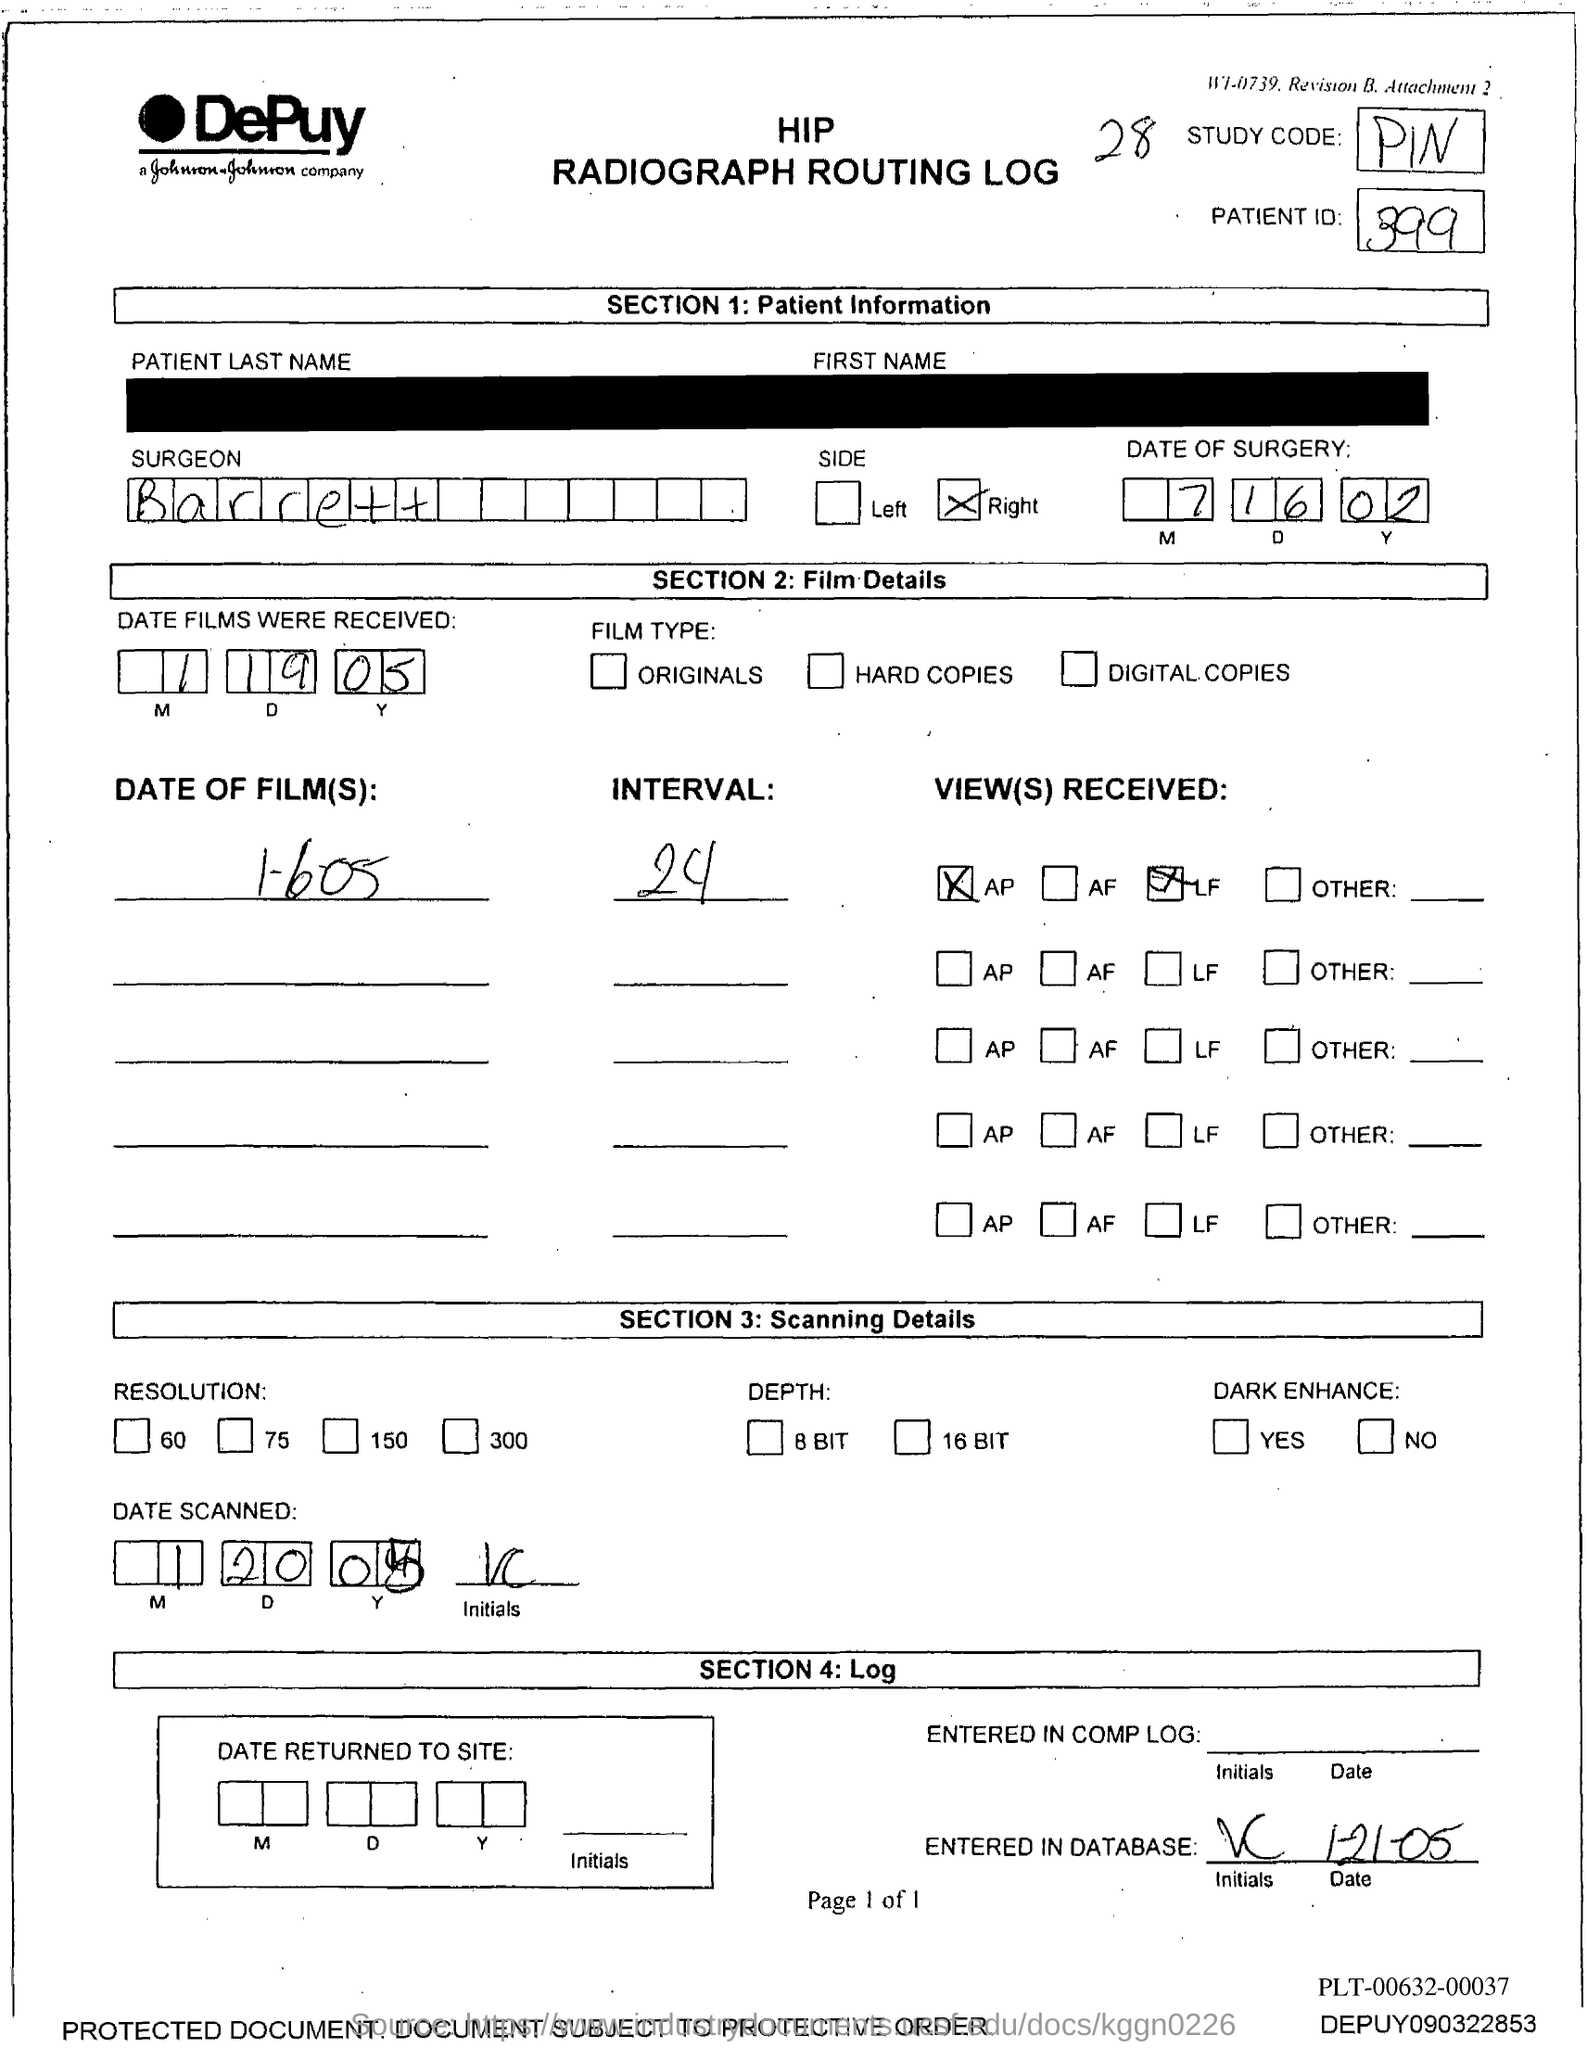Mention a couple of crucial points in this snapshot. The study code is PIN. What is the study code? The name of the surgeon is Barrett. The patient ID is 399... 